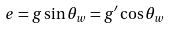Convert formula to latex. <formula><loc_0><loc_0><loc_500><loc_500>e = g \sin \theta _ { w } = g ^ { \prime } \cos \theta _ { w }</formula> 